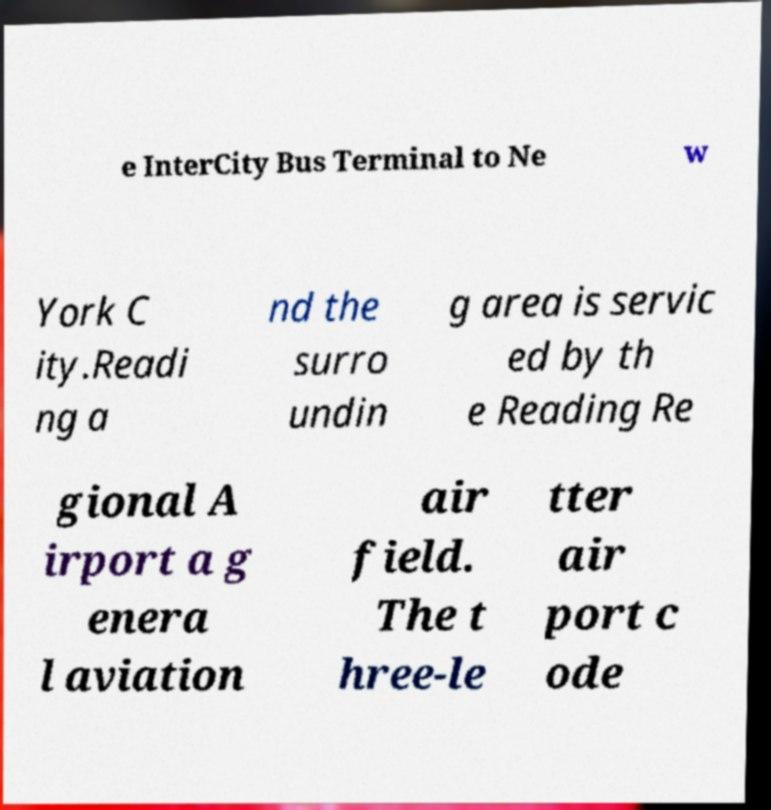Please identify and transcribe the text found in this image. e InterCity Bus Terminal to Ne w York C ity.Readi ng a nd the surro undin g area is servic ed by th e Reading Re gional A irport a g enera l aviation air field. The t hree-le tter air port c ode 